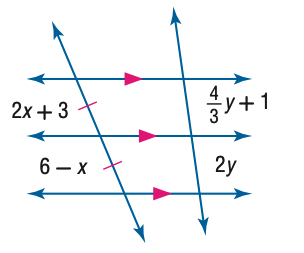Question: Find y.
Choices:
A. 1.0
B. 1.5
C. 2.0
D. 2.5
Answer with the letter. Answer: B 